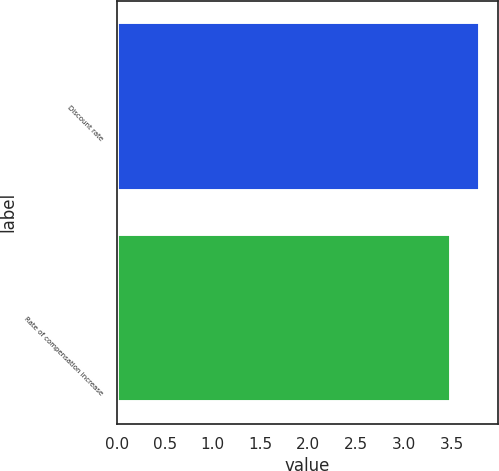<chart> <loc_0><loc_0><loc_500><loc_500><bar_chart><fcel>Discount rate<fcel>Rate of compensation increase<nl><fcel>3.8<fcel>3.5<nl></chart> 